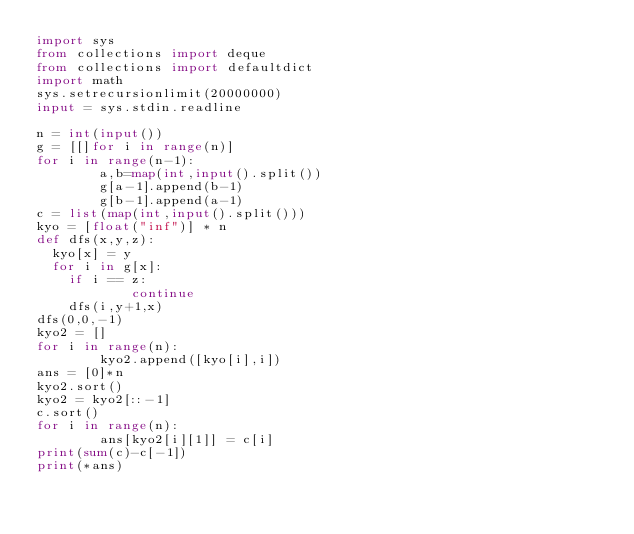<code> <loc_0><loc_0><loc_500><loc_500><_Python_>import sys
from collections import deque
from collections import defaultdict
import math
sys.setrecursionlimit(20000000)
input = sys.stdin.readline
 
n = int(input())
g = [[]for i in range(n)]
for i in range(n-1):
        a,b=map(int,input().split())
        g[a-1].append(b-1)
        g[b-1].append(a-1)
c = list(map(int,input().split()))
kyo = [float("inf")] * n
def dfs(x,y,z):
  kyo[x] = y
  for i in g[x]:
    if i == z:
            continue
    dfs(i,y+1,x)
dfs(0,0,-1)
kyo2 = []
for i in range(n):
        kyo2.append([kyo[i],i])
ans = [0]*n
kyo2.sort()
kyo2 = kyo2[::-1]
c.sort()
for i in range(n):
        ans[kyo2[i][1]] = c[i]
print(sum(c)-c[-1])
print(*ans)</code> 